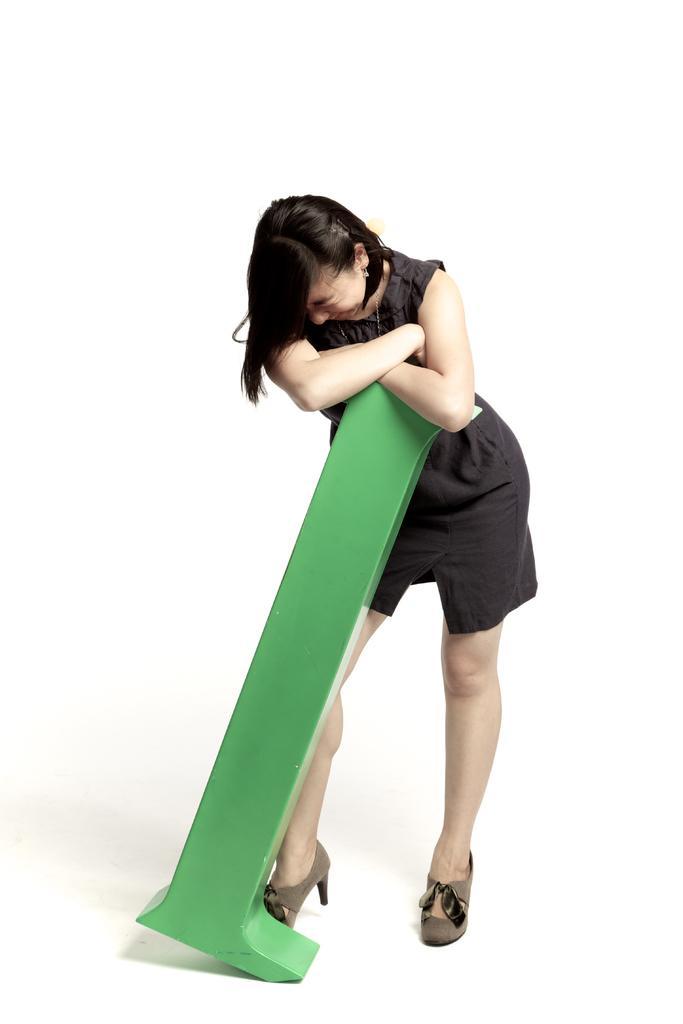In one or two sentences, can you explain what this image depicts? In the center of this picture there is a person wearing black color dress, holding a green color object and standing on the ground. The background of the image is white in color. 